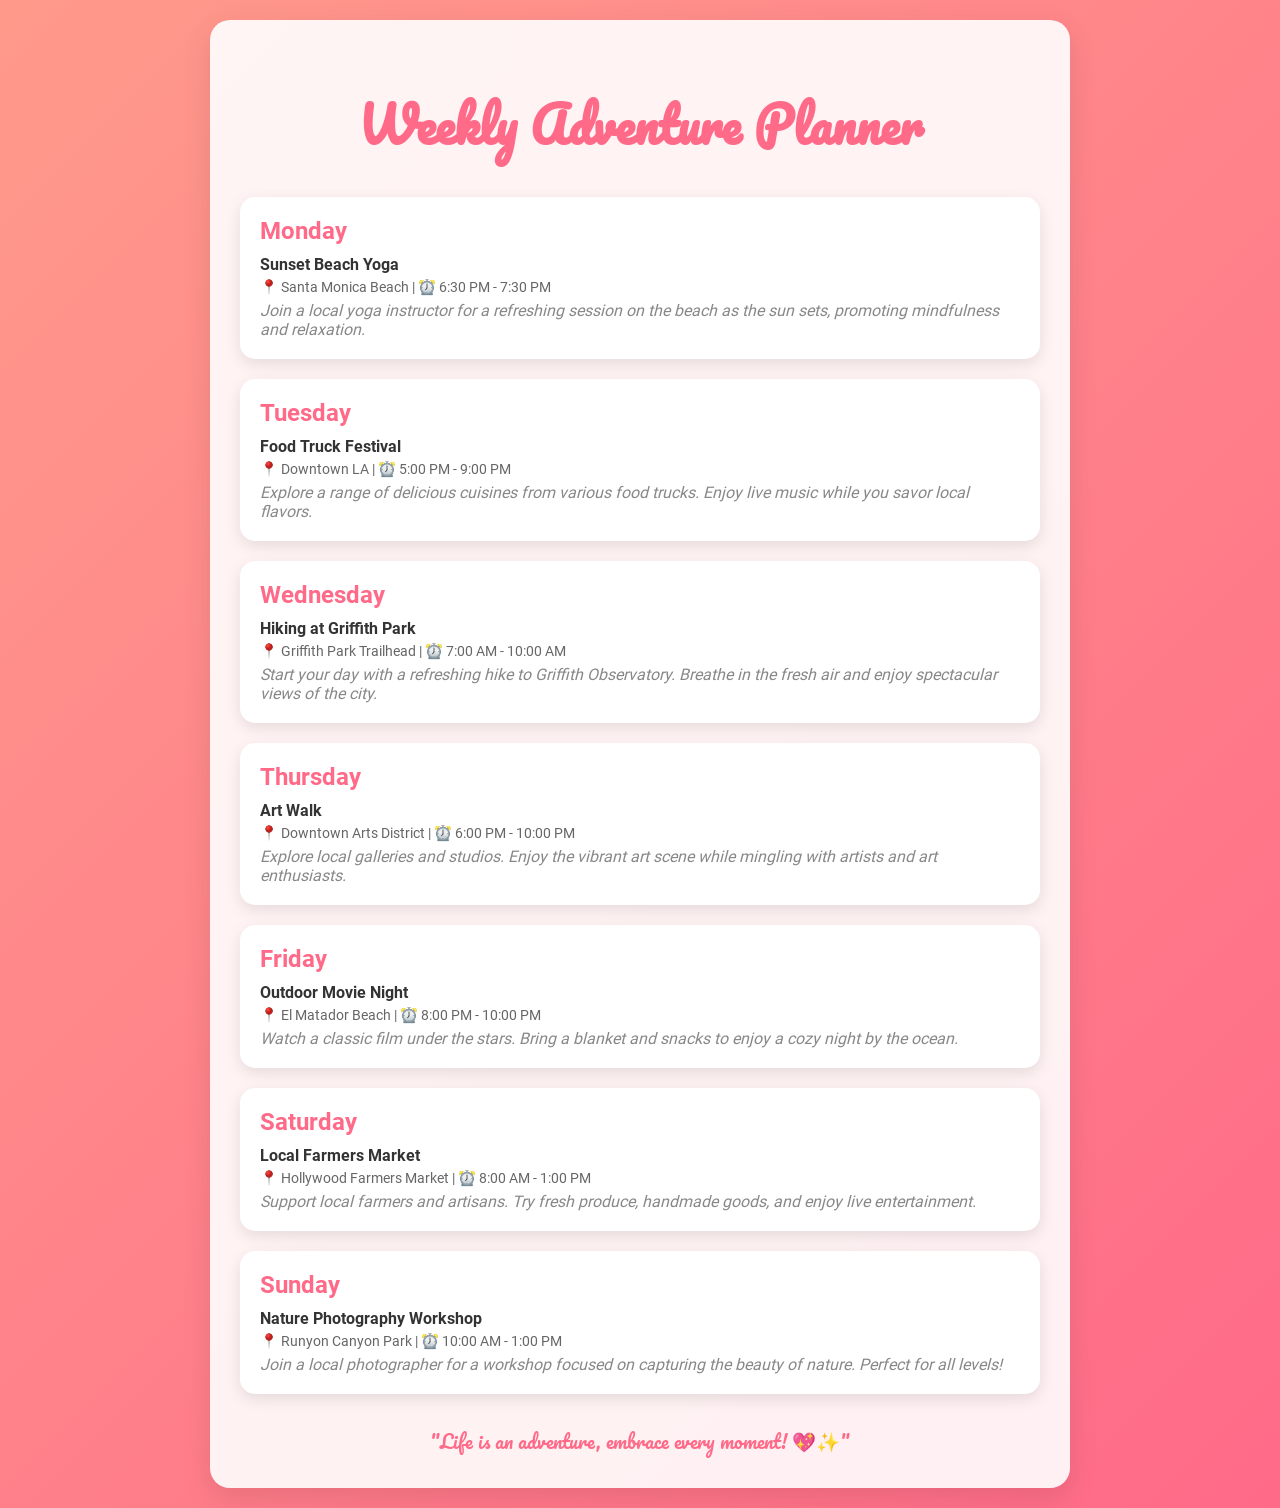What activity is scheduled for Monday? The document lists "Sunset Beach Yoga" as the activity for Monday.
Answer: Sunset Beach Yoga What time does the Food Truck Festival start? The Food Truck Festival starts at 5:00 PM on Tuesday according to the schedule.
Answer: 5:00 PM Where is the hiking activity taking place? The hiking activity is scheduled to take place at Griffith Park Trailhead on Wednesday.
Answer: Griffith Park Trailhead Which day features an Art Walk? The document indicates that the Art Walk is scheduled for Thursday.
Answer: Thursday What is the duration of the Outdoor Movie Night? The Outdoor Movie Night takes place from 8:00 PM to 10:00 PM, making it a 2-hour event.
Answer: 2 hours What type of workshop is offered on Sunday? The workshop scheduled for Sunday is a "Nature Photography Workshop."
Answer: Nature Photography Workshop How many activities occur in the evening? There are three activities (Yoga, Art Walk, and Outdoor Movie Night) scheduled in the evening.
Answer: Three Which activity has a location at El Matador Beach? The activity referred to is the "Outdoor Movie Night" mentioned for Friday.
Answer: Outdoor Movie Night What is the main theme of this Weekly Adventure Planner? The main theme is about engaging in local activities and experiences to elevate everyday life.
Answer: Local activities and experiences 